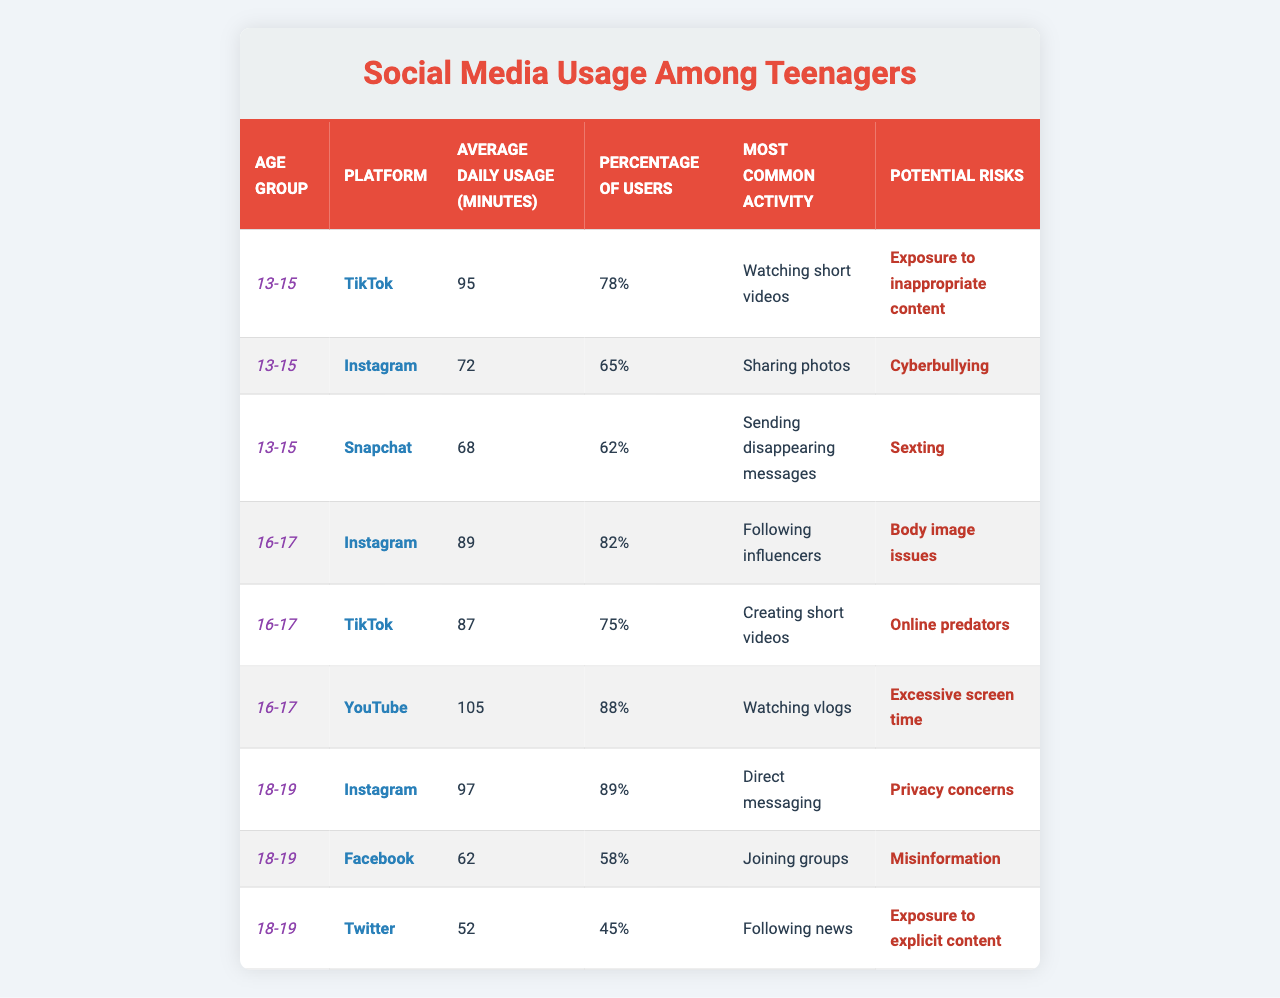What is the average daily usage of TikTok for the 13-15 age group? According to the table, the average daily usage of TikTok for the 13-15 age group is listed as 95 minutes.
Answer: 95 minutes What percentage of 18-19-year-olds use Instagram? The table shows that 89% of 18-19-year-olds are users of Instagram.
Answer: 89% How much more average daily usage do 18-19-year-olds spend on Instagram compared to 18-19-year-olds on Twitter? For Instagram, the average daily usage is 97 minutes, while for Twitter it is 52 minutes. The difference is 97 - 52 = 45 minutes.
Answer: 45 minutes Is the most common activity for Snapchat among the 13-15 age group sending disappearing messages? The table indicates that the most common activity for Snapchat in the 13-15 age group is indeed sending disappearing messages.
Answer: Yes What platforms show average daily usage over 80 minutes for the age group 16-17? The table indicates that for age group 16-17, YouTube has an average daily usage of 105 minutes, Instagram 89 minutes, and TikTok 87 minutes, all of which are over 80 minutes.
Answer: YouTube, Instagram, TikTok What is the potential risk associated with the most common activity of the 16-17 age group on TikTok? The most common activity for the 16-17 age group on TikTok is creating short videos, and the potential risk associated with this is online predators.
Answer: Online predators If we combine the percentage of users for Snapchat and Instagram in the 13-15 age group, what total percentage do we get? The percentage of users for Snapchat among 13-15 age group is 62%, and for Instagram, it is 65%. Adding them together gives 62 + 65 = 127%.
Answer: 127% Which age group spends the most time on YouTube daily, and how much time do they spend? The table shows that the age group 16-17 spends the most time on YouTube daily, with an average of 105 minutes.
Answer: 16-17 age group; 105 minutes What is the most common activity on Instagram for the 16-17 age group? The table states that the most common activity for Instagram in the 16-17 age group is following influencers.
Answer: Following influencers How does the potential risk of cyberbullying compare between Instagram and Snapchat for the 13-15 age group? The potential risk for Instagram is cyberbullying, and for Snapchat, it is sexting. Both are serious issues, but they are different risks.
Answer: Different risks 